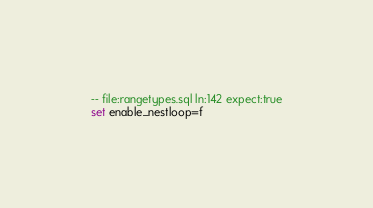<code> <loc_0><loc_0><loc_500><loc_500><_SQL_>-- file:rangetypes.sql ln:142 expect:true
set enable_nestloop=f
</code> 